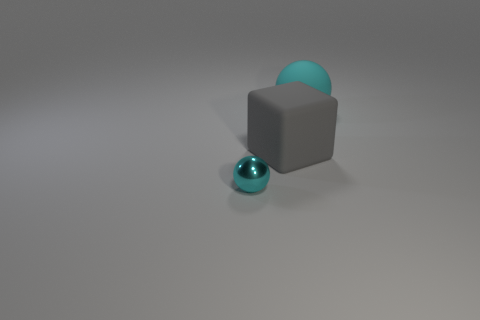What number of objects are large rubber things that are on the right side of the gray matte cube or gray rubber objects that are in front of the cyan rubber object?
Your answer should be compact. 2. Are there the same number of large rubber things and small cyan things?
Make the answer very short. No. How many objects are either rubber balls or big gray matte spheres?
Offer a terse response. 1. There is a large rubber object that is in front of the big cyan object; what number of objects are left of it?
Give a very brief answer. 1. What number of other things are the same size as the cyan rubber sphere?
Keep it short and to the point. 1. What is the size of the rubber sphere that is the same color as the tiny thing?
Offer a very short reply. Large. Does the cyan thing that is on the left side of the gray thing have the same shape as the cyan rubber thing?
Your response must be concise. Yes. What is the sphere that is on the right side of the tiny metallic ball made of?
Ensure brevity in your answer.  Rubber. There is a big thing that is the same color as the tiny object; what is its shape?
Give a very brief answer. Sphere. Are there any blue cylinders made of the same material as the large gray block?
Keep it short and to the point. No. 